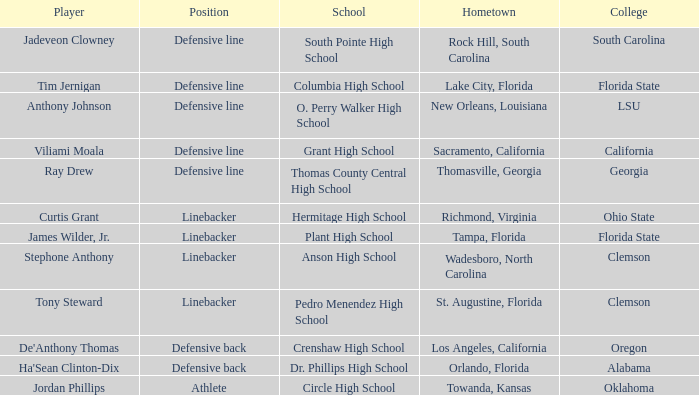Could you help me parse every detail presented in this table? {'header': ['Player', 'Position', 'School', 'Hometown', 'College'], 'rows': [['Jadeveon Clowney', 'Defensive line', 'South Pointe High School', 'Rock Hill, South Carolina', 'South Carolina'], ['Tim Jernigan', 'Defensive line', 'Columbia High School', 'Lake City, Florida', 'Florida State'], ['Anthony Johnson', 'Defensive line', 'O. Perry Walker High School', 'New Orleans, Louisiana', 'LSU'], ['Viliami Moala', 'Defensive line', 'Grant High School', 'Sacramento, California', 'California'], ['Ray Drew', 'Defensive line', 'Thomas County Central High School', 'Thomasville, Georgia', 'Georgia'], ['Curtis Grant', 'Linebacker', 'Hermitage High School', 'Richmond, Virginia', 'Ohio State'], ['James Wilder, Jr.', 'Linebacker', 'Plant High School', 'Tampa, Florida', 'Florida State'], ['Stephone Anthony', 'Linebacker', 'Anson High School', 'Wadesboro, North Carolina', 'Clemson'], ['Tony Steward', 'Linebacker', 'Pedro Menendez High School', 'St. Augustine, Florida', 'Clemson'], ["De'Anthony Thomas", 'Defensive back', 'Crenshaw High School', 'Los Angeles, California', 'Oregon'], ["Ha'Sean Clinton-Dix", 'Defensive back', 'Dr. Phillips High School', 'Orlando, Florida', 'Alabama'], ['Jordan Phillips', 'Athlete', 'Circle High School', 'Towanda, Kansas', 'Oklahoma']]} Which hometown has a player of Ray Drew? Thomasville, Georgia. 